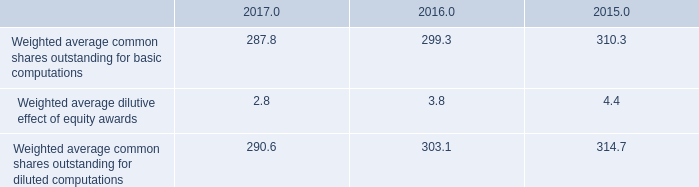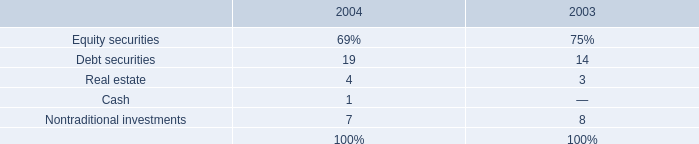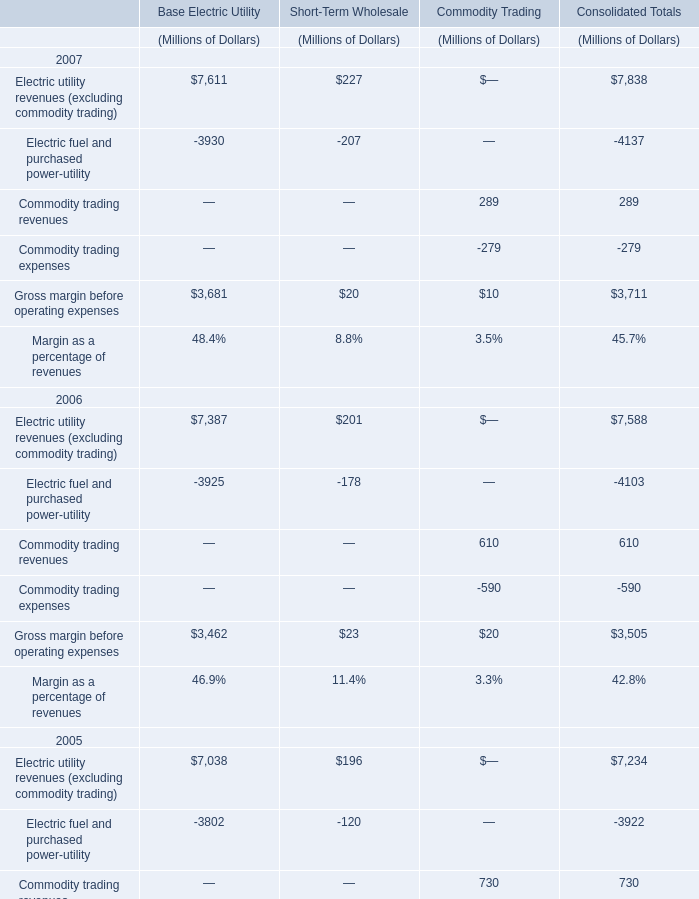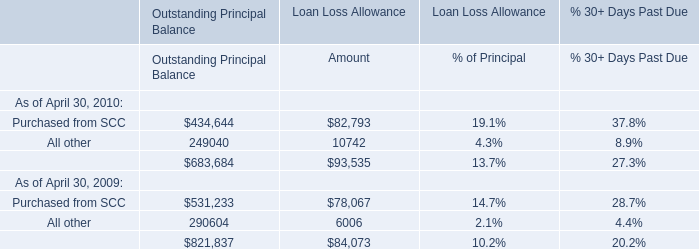As As the chart 2 shows,what is the value of the Commodity trading revenues for Commodity Trading in 2006? (in million) 
Answer: 610. 